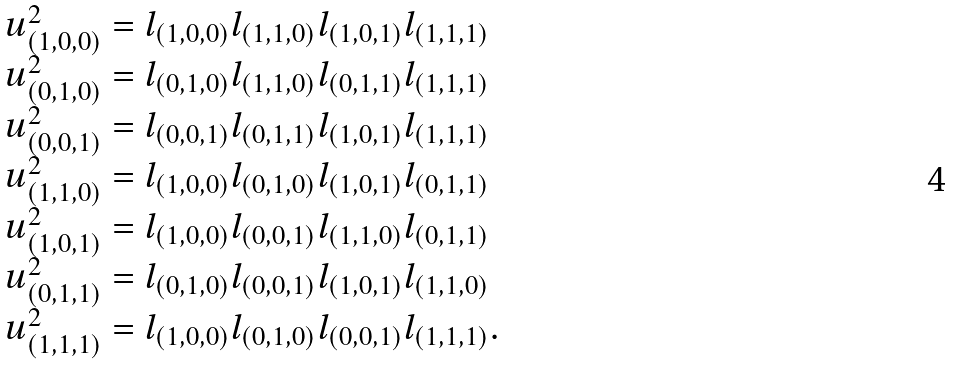<formula> <loc_0><loc_0><loc_500><loc_500>\begin{array} { l } u _ { ( 1 , 0 , 0 ) } ^ { 2 } = l _ { ( 1 , 0 , 0 ) } l _ { ( 1 , 1 , 0 ) } l _ { ( 1 , 0 , 1 ) } l _ { ( 1 , 1 , 1 ) } \\ u _ { ( 0 , 1 , 0 ) } ^ { 2 } = l _ { ( 0 , 1 , 0 ) } l _ { ( 1 , 1 , 0 ) } l _ { ( 0 , 1 , 1 ) } l _ { ( 1 , 1 , 1 ) } \\ u _ { ( 0 , 0 , 1 ) } ^ { 2 } = l _ { ( 0 , 0 , 1 ) } l _ { ( 0 , 1 , 1 ) } l _ { ( 1 , 0 , 1 ) } l _ { ( 1 , 1 , 1 ) } \\ u _ { ( 1 , 1 , 0 ) } ^ { 2 } = l _ { ( 1 , 0 , 0 ) } l _ { ( 0 , 1 , 0 ) } l _ { ( 1 , 0 , 1 ) } l _ { ( 0 , 1 , 1 ) } \\ u _ { ( 1 , 0 , 1 ) } ^ { 2 } = l _ { ( 1 , 0 , 0 ) } l _ { ( 0 , 0 , 1 ) } l _ { ( 1 , 1 , 0 ) } l _ { ( 0 , 1 , 1 ) } \\ u _ { ( 0 , 1 , 1 ) } ^ { 2 } = l _ { ( 0 , 1 , 0 ) } l _ { ( 0 , 0 , 1 ) } l _ { ( 1 , 0 , 1 ) } l _ { ( 1 , 1 , 0 ) } \\ u _ { ( 1 , 1 , 1 ) } ^ { 2 } = l _ { ( 1 , 0 , 0 ) } l _ { ( 0 , 1 , 0 ) } l _ { ( 0 , 0 , 1 ) } l _ { ( 1 , 1 , 1 ) } . \end{array}</formula> 